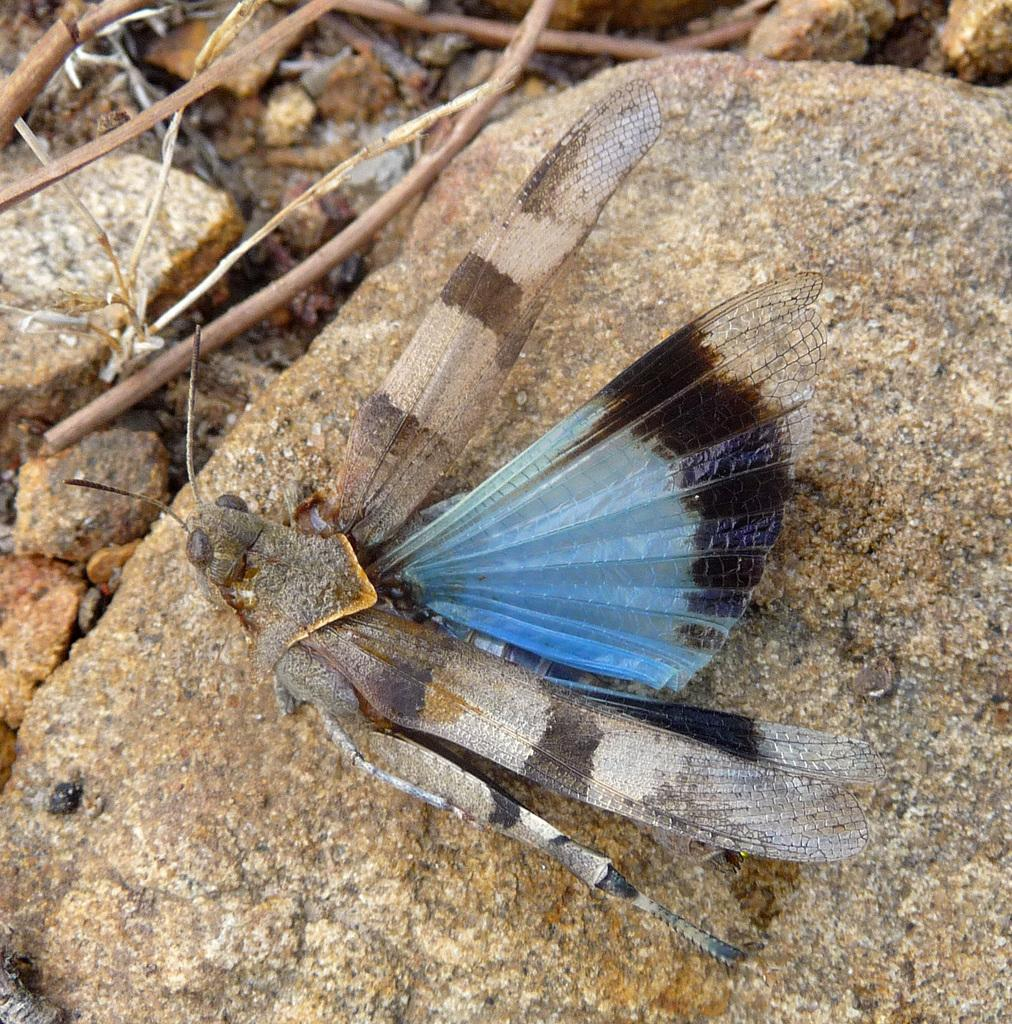What is the main subject in the center of the image? There is a fly in the center of the image. What can be seen in the background of the image? There are rocks in the background of the image. Are there any other objects or natural elements visible in the image? Yes, there are twigs visible in the image. What type of wrench can be seen in the image? There is no wrench present in the image. How does the light affect the appearance of the fly in the image? There is no mention of light in the image, so we cannot determine how it affects the appearance of the fly. 